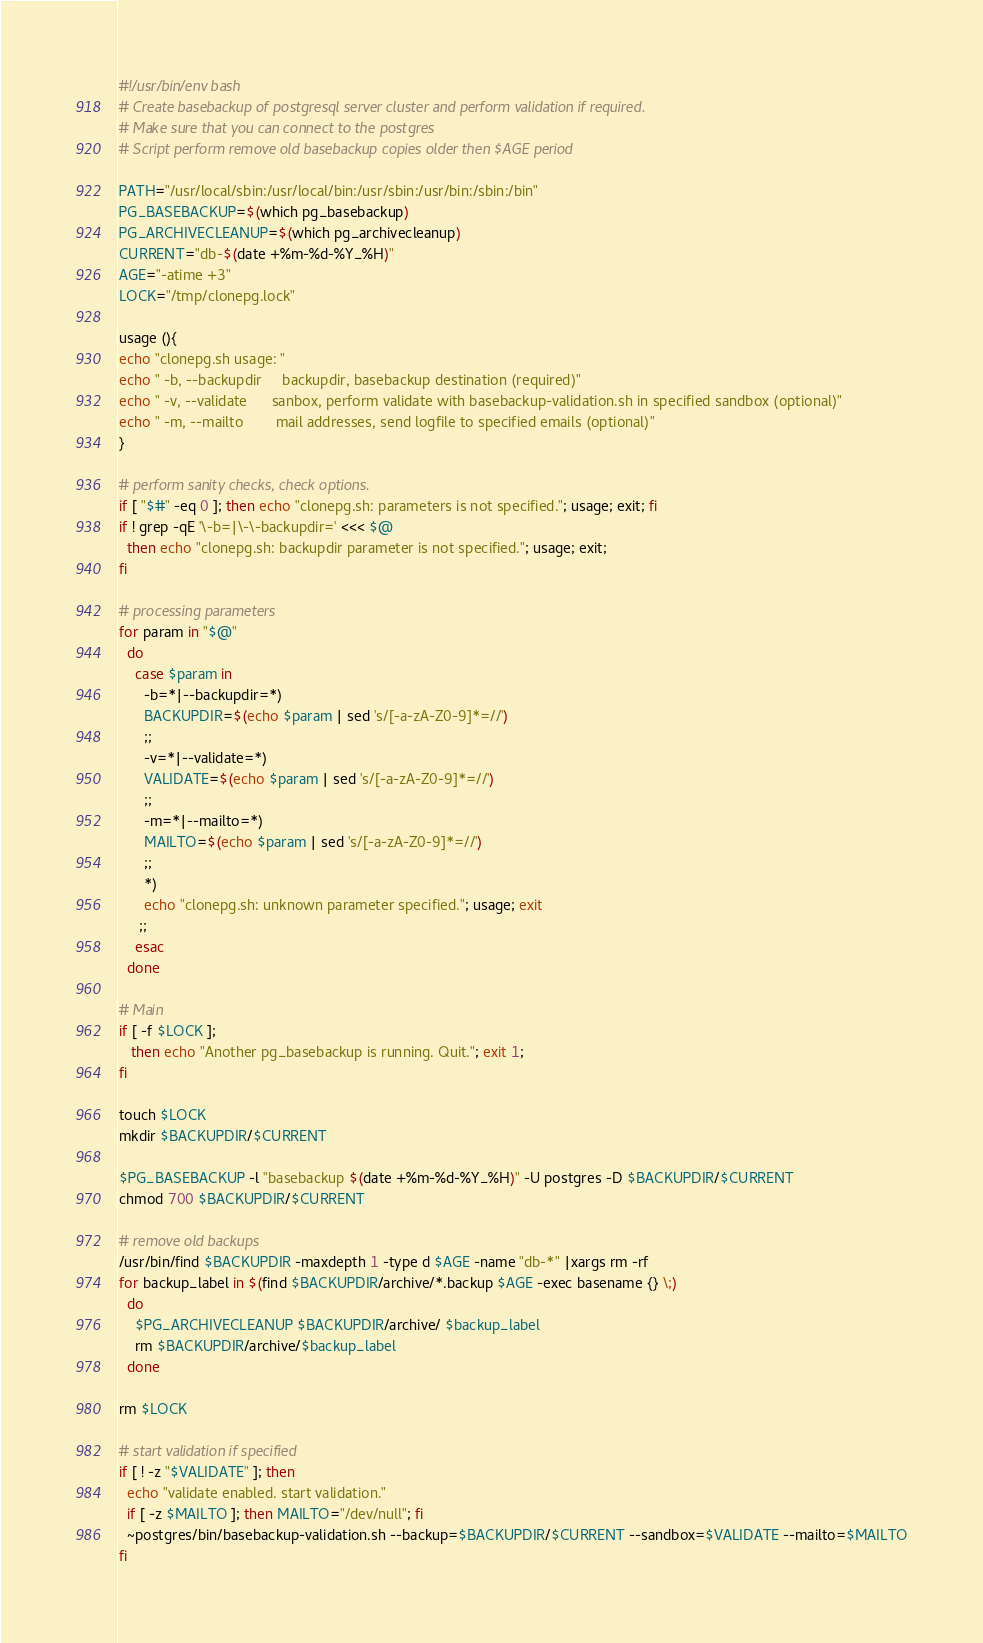Convert code to text. <code><loc_0><loc_0><loc_500><loc_500><_Bash_>#!/usr/bin/env bash
# Create basebackup of postgresql server cluster and perform validation if required.
# Make sure that you can connect to the postgres
# Script perform remove old basebackup copies older then $AGE period 

PATH="/usr/local/sbin:/usr/local/bin:/usr/sbin:/usr/bin:/sbin:/bin"
PG_BASEBACKUP=$(which pg_basebackup)
PG_ARCHIVECLEANUP=$(which pg_archivecleanup)
CURRENT="db-$(date +%m-%d-%Y_%H)"
AGE="-atime +3"
LOCK="/tmp/clonepg.lock"

usage (){
echo "clonepg.sh usage: "
echo " -b, --backupdir     backupdir, basebackup destination (required)"
echo " -v, --validate      sanbox, perform validate with basebackup-validation.sh in specified sandbox (optional)"
echo " -m, --mailto        mail addresses, send logfile to specified emails (optional)"
}

# perform sanity checks, check options.
if [ "$#" -eq 0 ]; then echo "clonepg.sh: parameters is not specified."; usage; exit; fi
if ! grep -qE '\-b=|\-\-backupdir=' <<< $@
  then echo "clonepg.sh: backupdir parameter is not specified."; usage; exit; 
fi

# processing parameters
for param in "$@"
  do
    case $param in
      -b=*|--backupdir=*)
      BACKUPDIR=$(echo $param | sed 's/[-a-zA-Z0-9]*=//')
      ;;
      -v=*|--validate=*)
      VALIDATE=$(echo $param | sed 's/[-a-zA-Z0-9]*=//')
      ;;
      -m=*|--mailto=*)
      MAILTO=$(echo $param | sed 's/[-a-zA-Z0-9]*=//')
      ;;
      *)
      echo "clonepg.sh: unknown parameter specified."; usage; exit
     ;;
    esac
  done

# Main 
if [ -f $LOCK ]; 
   then echo "Another pg_basebackup is running. Quit."; exit 1;
fi

touch $LOCK
mkdir $BACKUPDIR/$CURRENT

$PG_BASEBACKUP -l "basebackup $(date +%m-%d-%Y_%H)" -U postgres -D $BACKUPDIR/$CURRENT
chmod 700 $BACKUPDIR/$CURRENT

# remove old backups
/usr/bin/find $BACKUPDIR -maxdepth 1 -type d $AGE -name "db-*" |xargs rm -rf
for backup_label in $(find $BACKUPDIR/archive/*.backup $AGE -exec basename {} \;)
  do
    $PG_ARCHIVECLEANUP $BACKUPDIR/archive/ $backup_label
    rm $BACKUPDIR/archive/$backup_label
  done

rm $LOCK

# start validation if specified
if [ ! -z "$VALIDATE" ]; then
  echo "validate enabled. start validation."
  if [ -z $MAILTO ]; then MAILTO="/dev/null"; fi 
  ~postgres/bin/basebackup-validation.sh --backup=$BACKUPDIR/$CURRENT --sandbox=$VALIDATE --mailto=$MAILTO
fi
</code> 